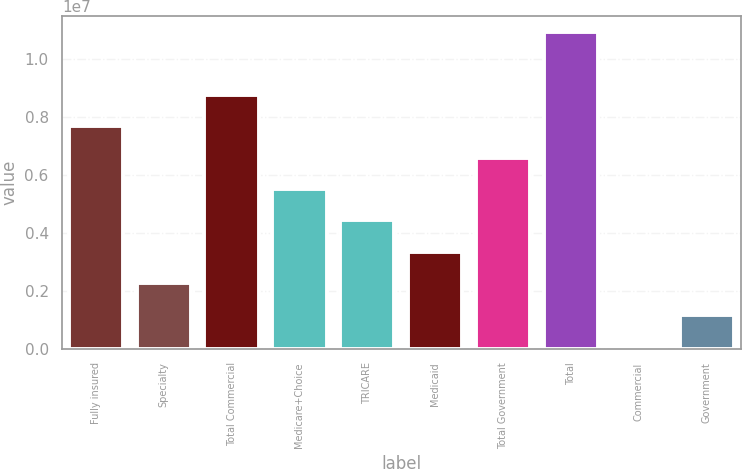<chart> <loc_0><loc_0><loc_500><loc_500><bar_chart><fcel>Fully insured<fcel>Specialty<fcel>Total Commercial<fcel>Medicare+Choice<fcel>TRICARE<fcel>Medicaid<fcel>Total Government<fcel>Total<fcel>Commercial<fcel>Government<nl><fcel>7.68224e+06<fcel>2.26864e+06<fcel>8.76496e+06<fcel>5.5168e+06<fcel>4.43408e+06<fcel>3.35136e+06<fcel>6.59952e+06<fcel>1.09304e+07<fcel>103203<fcel>1.18592e+06<nl></chart> 